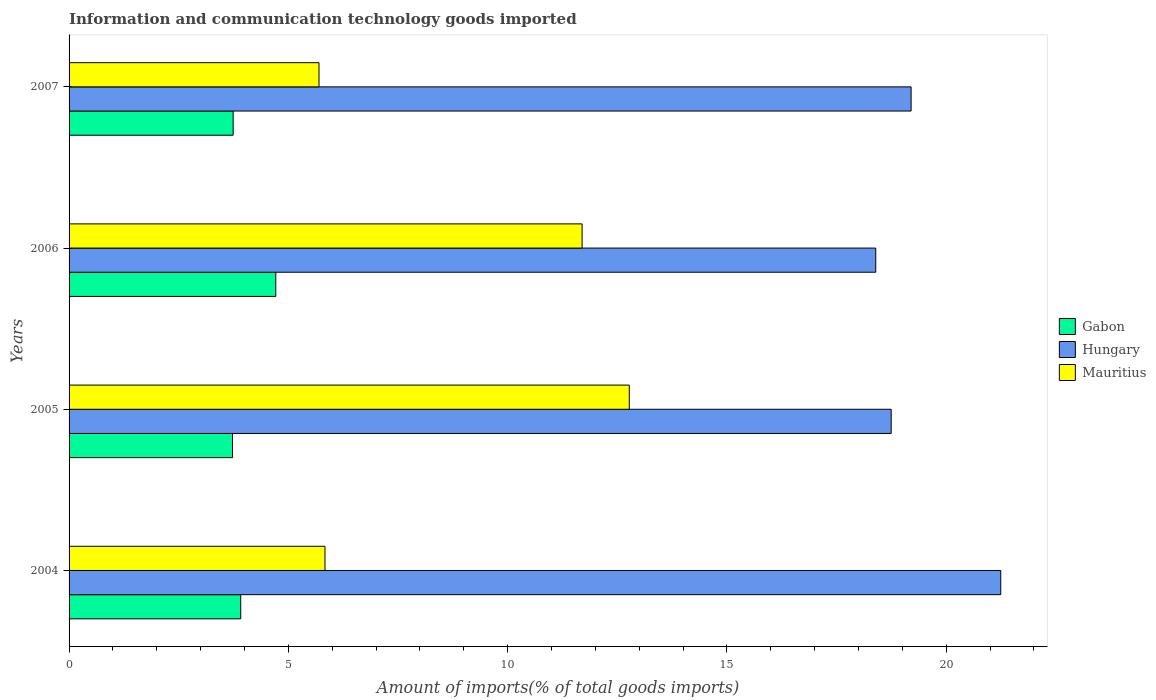Are the number of bars per tick equal to the number of legend labels?
Ensure brevity in your answer.  Yes. How many bars are there on the 4th tick from the top?
Provide a short and direct response. 3. What is the label of the 3rd group of bars from the top?
Give a very brief answer. 2005. What is the amount of goods imported in Gabon in 2006?
Give a very brief answer. 4.71. Across all years, what is the maximum amount of goods imported in Gabon?
Your response must be concise. 4.71. Across all years, what is the minimum amount of goods imported in Gabon?
Your response must be concise. 3.73. In which year was the amount of goods imported in Mauritius maximum?
Provide a succinct answer. 2005. What is the total amount of goods imported in Mauritius in the graph?
Make the answer very short. 36.01. What is the difference between the amount of goods imported in Gabon in 2006 and that in 2007?
Your answer should be compact. 0.97. What is the difference between the amount of goods imported in Hungary in 2004 and the amount of goods imported in Mauritius in 2005?
Your response must be concise. 8.47. What is the average amount of goods imported in Hungary per year?
Provide a short and direct response. 19.4. In the year 2006, what is the difference between the amount of goods imported in Mauritius and amount of goods imported in Hungary?
Make the answer very short. -6.7. In how many years, is the amount of goods imported in Mauritius greater than 20 %?
Make the answer very short. 0. What is the ratio of the amount of goods imported in Gabon in 2005 to that in 2006?
Keep it short and to the point. 0.79. What is the difference between the highest and the second highest amount of goods imported in Hungary?
Provide a succinct answer. 2.04. What is the difference between the highest and the lowest amount of goods imported in Mauritius?
Your answer should be very brief. 7.08. In how many years, is the amount of goods imported in Mauritius greater than the average amount of goods imported in Mauritius taken over all years?
Ensure brevity in your answer.  2. What does the 2nd bar from the top in 2007 represents?
Make the answer very short. Hungary. What does the 1st bar from the bottom in 2006 represents?
Offer a very short reply. Gabon. Is it the case that in every year, the sum of the amount of goods imported in Gabon and amount of goods imported in Mauritius is greater than the amount of goods imported in Hungary?
Offer a very short reply. No. How many bars are there?
Your answer should be compact. 12. Are all the bars in the graph horizontal?
Provide a succinct answer. Yes. What is the difference between two consecutive major ticks on the X-axis?
Offer a terse response. 5. Are the values on the major ticks of X-axis written in scientific E-notation?
Give a very brief answer. No. Does the graph contain grids?
Offer a very short reply. No. How many legend labels are there?
Make the answer very short. 3. What is the title of the graph?
Provide a short and direct response. Information and communication technology goods imported. What is the label or title of the X-axis?
Keep it short and to the point. Amount of imports(% of total goods imports). What is the label or title of the Y-axis?
Provide a succinct answer. Years. What is the Amount of imports(% of total goods imports) of Gabon in 2004?
Provide a succinct answer. 3.91. What is the Amount of imports(% of total goods imports) of Hungary in 2004?
Your answer should be very brief. 21.24. What is the Amount of imports(% of total goods imports) of Mauritius in 2004?
Give a very brief answer. 5.84. What is the Amount of imports(% of total goods imports) of Gabon in 2005?
Your response must be concise. 3.73. What is the Amount of imports(% of total goods imports) in Hungary in 2005?
Your answer should be compact. 18.75. What is the Amount of imports(% of total goods imports) in Mauritius in 2005?
Provide a succinct answer. 12.77. What is the Amount of imports(% of total goods imports) of Gabon in 2006?
Keep it short and to the point. 4.71. What is the Amount of imports(% of total goods imports) in Hungary in 2006?
Your answer should be very brief. 18.39. What is the Amount of imports(% of total goods imports) of Mauritius in 2006?
Provide a succinct answer. 11.7. What is the Amount of imports(% of total goods imports) in Gabon in 2007?
Your response must be concise. 3.74. What is the Amount of imports(% of total goods imports) in Hungary in 2007?
Your answer should be very brief. 19.2. What is the Amount of imports(% of total goods imports) in Mauritius in 2007?
Provide a succinct answer. 5.7. Across all years, what is the maximum Amount of imports(% of total goods imports) in Gabon?
Provide a short and direct response. 4.71. Across all years, what is the maximum Amount of imports(% of total goods imports) of Hungary?
Provide a short and direct response. 21.24. Across all years, what is the maximum Amount of imports(% of total goods imports) of Mauritius?
Your response must be concise. 12.77. Across all years, what is the minimum Amount of imports(% of total goods imports) in Gabon?
Make the answer very short. 3.73. Across all years, what is the minimum Amount of imports(% of total goods imports) of Hungary?
Offer a very short reply. 18.39. Across all years, what is the minimum Amount of imports(% of total goods imports) in Mauritius?
Your response must be concise. 5.7. What is the total Amount of imports(% of total goods imports) of Gabon in the graph?
Offer a terse response. 16.1. What is the total Amount of imports(% of total goods imports) of Hungary in the graph?
Make the answer very short. 77.58. What is the total Amount of imports(% of total goods imports) of Mauritius in the graph?
Offer a terse response. 36.01. What is the difference between the Amount of imports(% of total goods imports) of Gabon in 2004 and that in 2005?
Your answer should be compact. 0.19. What is the difference between the Amount of imports(% of total goods imports) of Hungary in 2004 and that in 2005?
Provide a short and direct response. 2.5. What is the difference between the Amount of imports(% of total goods imports) in Mauritius in 2004 and that in 2005?
Keep it short and to the point. -6.94. What is the difference between the Amount of imports(% of total goods imports) in Gabon in 2004 and that in 2006?
Your answer should be very brief. -0.8. What is the difference between the Amount of imports(% of total goods imports) in Hungary in 2004 and that in 2006?
Make the answer very short. 2.85. What is the difference between the Amount of imports(% of total goods imports) in Mauritius in 2004 and that in 2006?
Provide a succinct answer. -5.86. What is the difference between the Amount of imports(% of total goods imports) in Gabon in 2004 and that in 2007?
Make the answer very short. 0.17. What is the difference between the Amount of imports(% of total goods imports) in Hungary in 2004 and that in 2007?
Give a very brief answer. 2.04. What is the difference between the Amount of imports(% of total goods imports) in Mauritius in 2004 and that in 2007?
Provide a succinct answer. 0.14. What is the difference between the Amount of imports(% of total goods imports) of Gabon in 2005 and that in 2006?
Your answer should be compact. -0.99. What is the difference between the Amount of imports(% of total goods imports) in Hungary in 2005 and that in 2006?
Provide a short and direct response. 0.35. What is the difference between the Amount of imports(% of total goods imports) in Mauritius in 2005 and that in 2006?
Provide a short and direct response. 1.08. What is the difference between the Amount of imports(% of total goods imports) in Gabon in 2005 and that in 2007?
Your response must be concise. -0.01. What is the difference between the Amount of imports(% of total goods imports) in Hungary in 2005 and that in 2007?
Offer a terse response. -0.45. What is the difference between the Amount of imports(% of total goods imports) of Mauritius in 2005 and that in 2007?
Your response must be concise. 7.08. What is the difference between the Amount of imports(% of total goods imports) of Gabon in 2006 and that in 2007?
Your answer should be very brief. 0.97. What is the difference between the Amount of imports(% of total goods imports) in Hungary in 2006 and that in 2007?
Provide a short and direct response. -0.81. What is the difference between the Amount of imports(% of total goods imports) in Mauritius in 2006 and that in 2007?
Your answer should be very brief. 6. What is the difference between the Amount of imports(% of total goods imports) in Gabon in 2004 and the Amount of imports(% of total goods imports) in Hungary in 2005?
Your response must be concise. -14.83. What is the difference between the Amount of imports(% of total goods imports) of Gabon in 2004 and the Amount of imports(% of total goods imports) of Mauritius in 2005?
Offer a terse response. -8.86. What is the difference between the Amount of imports(% of total goods imports) in Hungary in 2004 and the Amount of imports(% of total goods imports) in Mauritius in 2005?
Offer a very short reply. 8.47. What is the difference between the Amount of imports(% of total goods imports) in Gabon in 2004 and the Amount of imports(% of total goods imports) in Hungary in 2006?
Provide a short and direct response. -14.48. What is the difference between the Amount of imports(% of total goods imports) of Gabon in 2004 and the Amount of imports(% of total goods imports) of Mauritius in 2006?
Give a very brief answer. -7.78. What is the difference between the Amount of imports(% of total goods imports) of Hungary in 2004 and the Amount of imports(% of total goods imports) of Mauritius in 2006?
Provide a succinct answer. 9.55. What is the difference between the Amount of imports(% of total goods imports) of Gabon in 2004 and the Amount of imports(% of total goods imports) of Hungary in 2007?
Provide a succinct answer. -15.29. What is the difference between the Amount of imports(% of total goods imports) of Gabon in 2004 and the Amount of imports(% of total goods imports) of Mauritius in 2007?
Make the answer very short. -1.78. What is the difference between the Amount of imports(% of total goods imports) of Hungary in 2004 and the Amount of imports(% of total goods imports) of Mauritius in 2007?
Offer a terse response. 15.55. What is the difference between the Amount of imports(% of total goods imports) of Gabon in 2005 and the Amount of imports(% of total goods imports) of Hungary in 2006?
Provide a short and direct response. -14.67. What is the difference between the Amount of imports(% of total goods imports) in Gabon in 2005 and the Amount of imports(% of total goods imports) in Mauritius in 2006?
Provide a succinct answer. -7.97. What is the difference between the Amount of imports(% of total goods imports) in Hungary in 2005 and the Amount of imports(% of total goods imports) in Mauritius in 2006?
Give a very brief answer. 7.05. What is the difference between the Amount of imports(% of total goods imports) of Gabon in 2005 and the Amount of imports(% of total goods imports) of Hungary in 2007?
Offer a very short reply. -15.47. What is the difference between the Amount of imports(% of total goods imports) in Gabon in 2005 and the Amount of imports(% of total goods imports) in Mauritius in 2007?
Your answer should be compact. -1.97. What is the difference between the Amount of imports(% of total goods imports) in Hungary in 2005 and the Amount of imports(% of total goods imports) in Mauritius in 2007?
Offer a very short reply. 13.05. What is the difference between the Amount of imports(% of total goods imports) of Gabon in 2006 and the Amount of imports(% of total goods imports) of Hungary in 2007?
Provide a succinct answer. -14.49. What is the difference between the Amount of imports(% of total goods imports) of Gabon in 2006 and the Amount of imports(% of total goods imports) of Mauritius in 2007?
Your response must be concise. -0.98. What is the difference between the Amount of imports(% of total goods imports) of Hungary in 2006 and the Amount of imports(% of total goods imports) of Mauritius in 2007?
Make the answer very short. 12.7. What is the average Amount of imports(% of total goods imports) of Gabon per year?
Offer a terse response. 4.02. What is the average Amount of imports(% of total goods imports) of Hungary per year?
Provide a short and direct response. 19.4. What is the average Amount of imports(% of total goods imports) of Mauritius per year?
Give a very brief answer. 9. In the year 2004, what is the difference between the Amount of imports(% of total goods imports) of Gabon and Amount of imports(% of total goods imports) of Hungary?
Keep it short and to the point. -17.33. In the year 2004, what is the difference between the Amount of imports(% of total goods imports) of Gabon and Amount of imports(% of total goods imports) of Mauritius?
Ensure brevity in your answer.  -1.92. In the year 2004, what is the difference between the Amount of imports(% of total goods imports) in Hungary and Amount of imports(% of total goods imports) in Mauritius?
Make the answer very short. 15.41. In the year 2005, what is the difference between the Amount of imports(% of total goods imports) in Gabon and Amount of imports(% of total goods imports) in Hungary?
Make the answer very short. -15.02. In the year 2005, what is the difference between the Amount of imports(% of total goods imports) in Gabon and Amount of imports(% of total goods imports) in Mauritius?
Your answer should be very brief. -9.05. In the year 2005, what is the difference between the Amount of imports(% of total goods imports) in Hungary and Amount of imports(% of total goods imports) in Mauritius?
Provide a short and direct response. 5.97. In the year 2006, what is the difference between the Amount of imports(% of total goods imports) of Gabon and Amount of imports(% of total goods imports) of Hungary?
Keep it short and to the point. -13.68. In the year 2006, what is the difference between the Amount of imports(% of total goods imports) of Gabon and Amount of imports(% of total goods imports) of Mauritius?
Provide a short and direct response. -6.98. In the year 2006, what is the difference between the Amount of imports(% of total goods imports) of Hungary and Amount of imports(% of total goods imports) of Mauritius?
Ensure brevity in your answer.  6.7. In the year 2007, what is the difference between the Amount of imports(% of total goods imports) in Gabon and Amount of imports(% of total goods imports) in Hungary?
Your answer should be very brief. -15.46. In the year 2007, what is the difference between the Amount of imports(% of total goods imports) of Gabon and Amount of imports(% of total goods imports) of Mauritius?
Your answer should be very brief. -1.96. In the year 2007, what is the difference between the Amount of imports(% of total goods imports) of Hungary and Amount of imports(% of total goods imports) of Mauritius?
Ensure brevity in your answer.  13.5. What is the ratio of the Amount of imports(% of total goods imports) of Gabon in 2004 to that in 2005?
Provide a short and direct response. 1.05. What is the ratio of the Amount of imports(% of total goods imports) in Hungary in 2004 to that in 2005?
Give a very brief answer. 1.13. What is the ratio of the Amount of imports(% of total goods imports) of Mauritius in 2004 to that in 2005?
Your answer should be compact. 0.46. What is the ratio of the Amount of imports(% of total goods imports) of Gabon in 2004 to that in 2006?
Your answer should be very brief. 0.83. What is the ratio of the Amount of imports(% of total goods imports) in Hungary in 2004 to that in 2006?
Keep it short and to the point. 1.16. What is the ratio of the Amount of imports(% of total goods imports) in Mauritius in 2004 to that in 2006?
Ensure brevity in your answer.  0.5. What is the ratio of the Amount of imports(% of total goods imports) in Gabon in 2004 to that in 2007?
Make the answer very short. 1.05. What is the ratio of the Amount of imports(% of total goods imports) in Hungary in 2004 to that in 2007?
Make the answer very short. 1.11. What is the ratio of the Amount of imports(% of total goods imports) of Mauritius in 2004 to that in 2007?
Your response must be concise. 1.02. What is the ratio of the Amount of imports(% of total goods imports) of Gabon in 2005 to that in 2006?
Your answer should be compact. 0.79. What is the ratio of the Amount of imports(% of total goods imports) in Hungary in 2005 to that in 2006?
Offer a very short reply. 1.02. What is the ratio of the Amount of imports(% of total goods imports) of Mauritius in 2005 to that in 2006?
Offer a terse response. 1.09. What is the ratio of the Amount of imports(% of total goods imports) in Gabon in 2005 to that in 2007?
Keep it short and to the point. 1. What is the ratio of the Amount of imports(% of total goods imports) in Hungary in 2005 to that in 2007?
Provide a succinct answer. 0.98. What is the ratio of the Amount of imports(% of total goods imports) of Mauritius in 2005 to that in 2007?
Make the answer very short. 2.24. What is the ratio of the Amount of imports(% of total goods imports) of Gabon in 2006 to that in 2007?
Keep it short and to the point. 1.26. What is the ratio of the Amount of imports(% of total goods imports) of Hungary in 2006 to that in 2007?
Your answer should be compact. 0.96. What is the ratio of the Amount of imports(% of total goods imports) of Mauritius in 2006 to that in 2007?
Your answer should be very brief. 2.05. What is the difference between the highest and the second highest Amount of imports(% of total goods imports) of Gabon?
Provide a short and direct response. 0.8. What is the difference between the highest and the second highest Amount of imports(% of total goods imports) of Hungary?
Keep it short and to the point. 2.04. What is the difference between the highest and the second highest Amount of imports(% of total goods imports) of Mauritius?
Offer a terse response. 1.08. What is the difference between the highest and the lowest Amount of imports(% of total goods imports) in Gabon?
Make the answer very short. 0.99. What is the difference between the highest and the lowest Amount of imports(% of total goods imports) in Hungary?
Your answer should be very brief. 2.85. What is the difference between the highest and the lowest Amount of imports(% of total goods imports) in Mauritius?
Give a very brief answer. 7.08. 